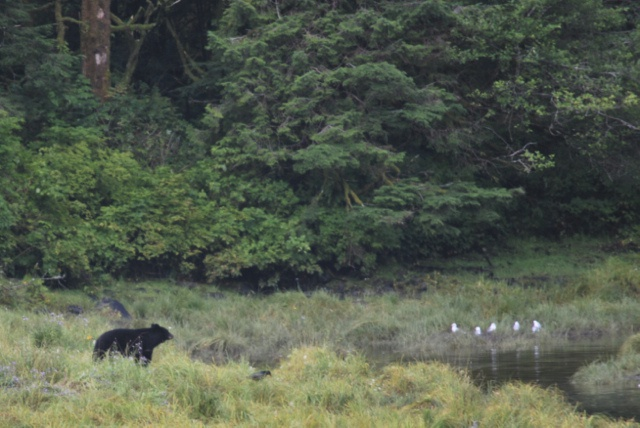Describe the objects in this image and their specific colors. I can see bear in black and gray tones, bird in black and gray tones, bird in black, darkgray, lavender, and gray tones, bird in black, darkgray, lavender, and lightgray tones, and bird in black, gray, lavender, and darkgray tones in this image. 